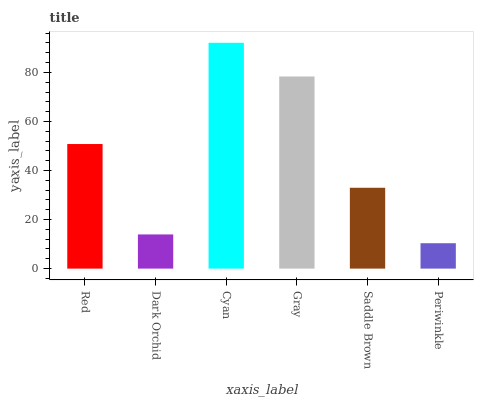Is Periwinkle the minimum?
Answer yes or no. Yes. Is Cyan the maximum?
Answer yes or no. Yes. Is Dark Orchid the minimum?
Answer yes or no. No. Is Dark Orchid the maximum?
Answer yes or no. No. Is Red greater than Dark Orchid?
Answer yes or no. Yes. Is Dark Orchid less than Red?
Answer yes or no. Yes. Is Dark Orchid greater than Red?
Answer yes or no. No. Is Red less than Dark Orchid?
Answer yes or no. No. Is Red the high median?
Answer yes or no. Yes. Is Saddle Brown the low median?
Answer yes or no. Yes. Is Saddle Brown the high median?
Answer yes or no. No. Is Dark Orchid the low median?
Answer yes or no. No. 